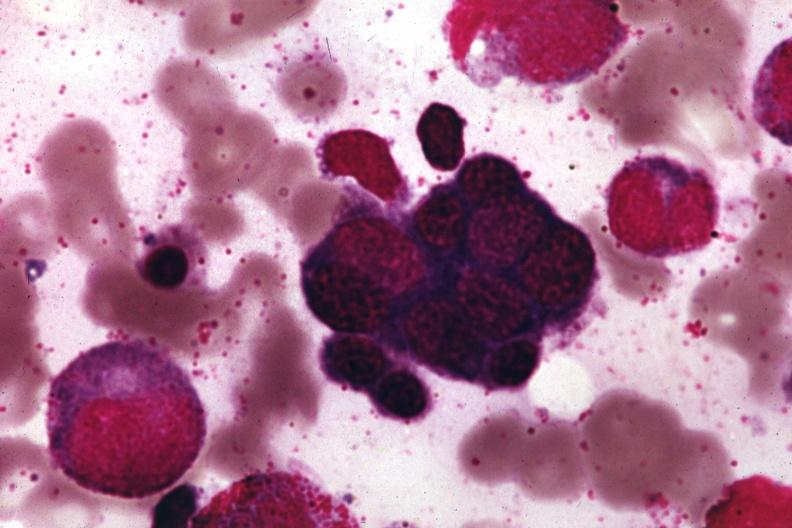does this image show wrights?
Answer the question using a single word or phrase. Yes 